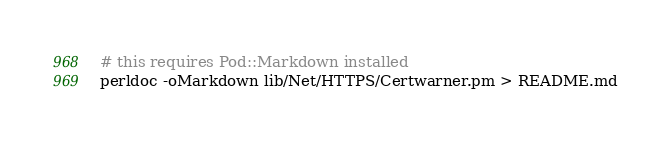Convert code to text. <code><loc_0><loc_0><loc_500><loc_500><_Bash_># this requires Pod::Markdown installed
perldoc -oMarkdown lib/Net/HTTPS/Certwarner.pm > README.md
</code> 